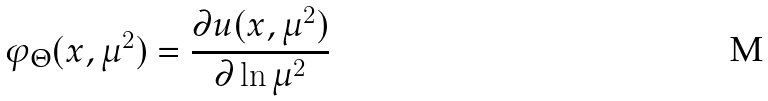Convert formula to latex. <formula><loc_0><loc_0><loc_500><loc_500>\varphi _ { \Theta } ( x , \mu ^ { 2 } ) = \frac { \partial u ( x , \mu ^ { 2 } ) } { \partial \ln \mu ^ { 2 } }</formula> 